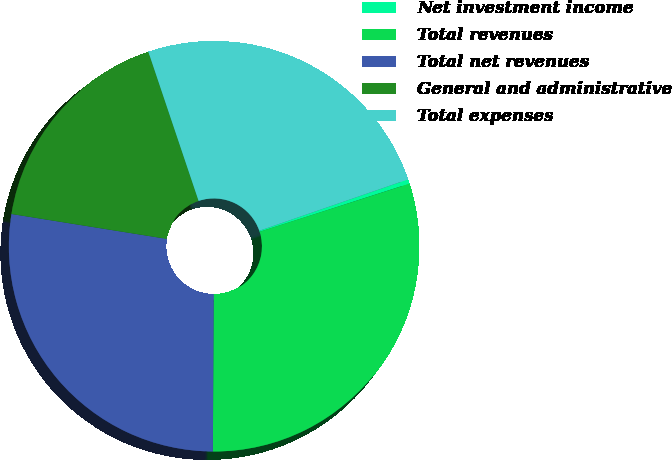<chart> <loc_0><loc_0><loc_500><loc_500><pie_chart><fcel>Net investment income<fcel>Total revenues<fcel>Total net revenues<fcel>General and administrative<fcel>Total expenses<nl><fcel>0.35%<fcel>30.03%<fcel>27.45%<fcel>17.3%<fcel>24.88%<nl></chart> 